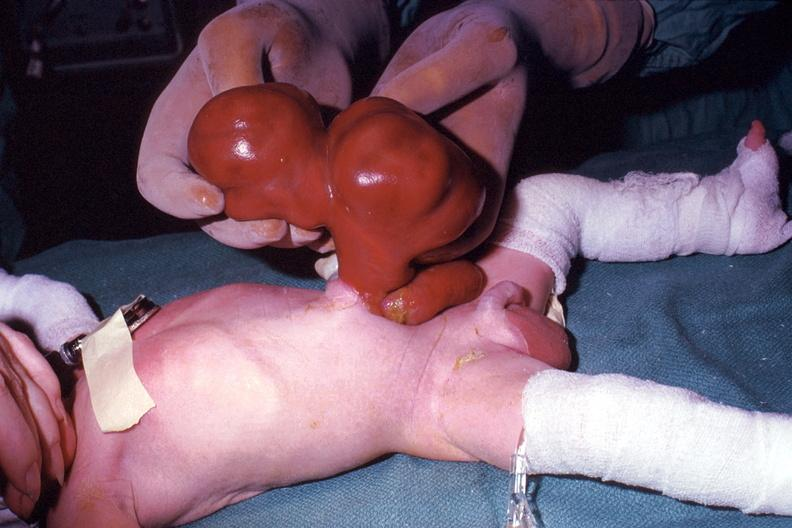what is present?
Answer the question using a single word or phrase. Abdomen 